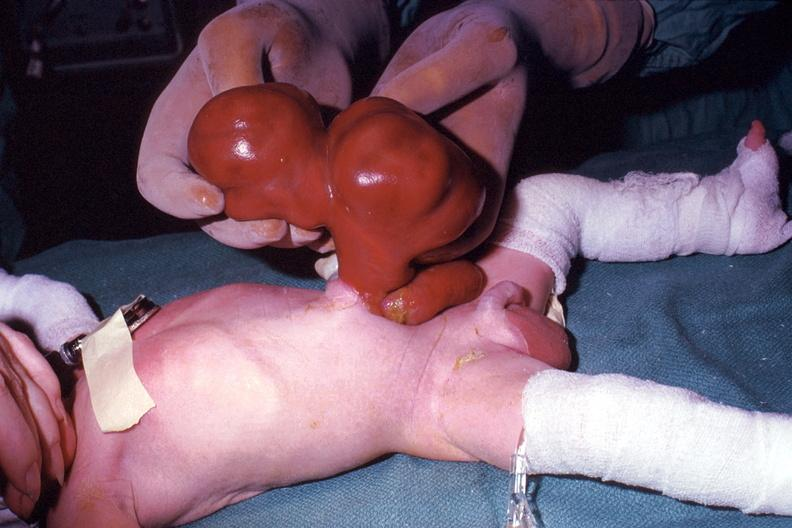what is present?
Answer the question using a single word or phrase. Abdomen 